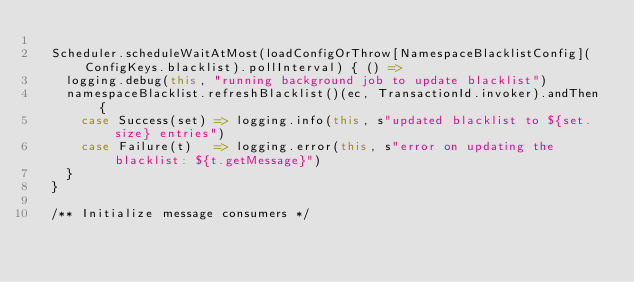<code> <loc_0><loc_0><loc_500><loc_500><_Scala_>
  Scheduler.scheduleWaitAtMost(loadConfigOrThrow[NamespaceBlacklistConfig](ConfigKeys.blacklist).pollInterval) { () =>
    logging.debug(this, "running background job to update blacklist")
    namespaceBlacklist.refreshBlacklist()(ec, TransactionId.invoker).andThen {
      case Success(set) => logging.info(this, s"updated blacklist to ${set.size} entries")
      case Failure(t)   => logging.error(this, s"error on updating the blacklist: ${t.getMessage}")
    }
  }

  /** Initialize message consumers */</code> 